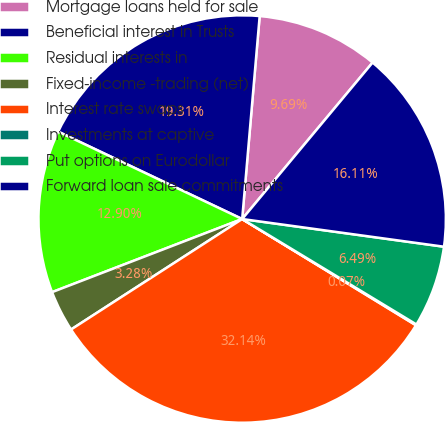Convert chart. <chart><loc_0><loc_0><loc_500><loc_500><pie_chart><fcel>Mortgage loans held for sale<fcel>Beneficial interest in Trusts<fcel>Residual interests in<fcel>Fixed-income -trading (net)<fcel>Interest rate swaps<fcel>Investments at captive<fcel>Put options on Eurodollar<fcel>Forward loan sale commitments<nl><fcel>9.69%<fcel>19.31%<fcel>12.9%<fcel>3.28%<fcel>32.14%<fcel>0.07%<fcel>6.49%<fcel>16.11%<nl></chart> 